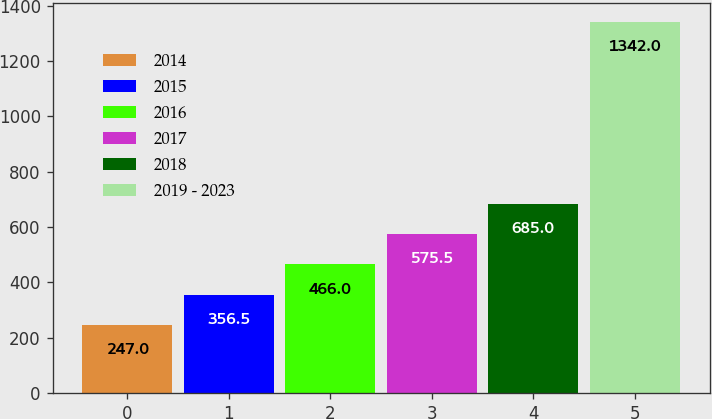Convert chart to OTSL. <chart><loc_0><loc_0><loc_500><loc_500><bar_chart><fcel>2014<fcel>2015<fcel>2016<fcel>2017<fcel>2018<fcel>2019 - 2023<nl><fcel>247<fcel>356.5<fcel>466<fcel>575.5<fcel>685<fcel>1342<nl></chart> 